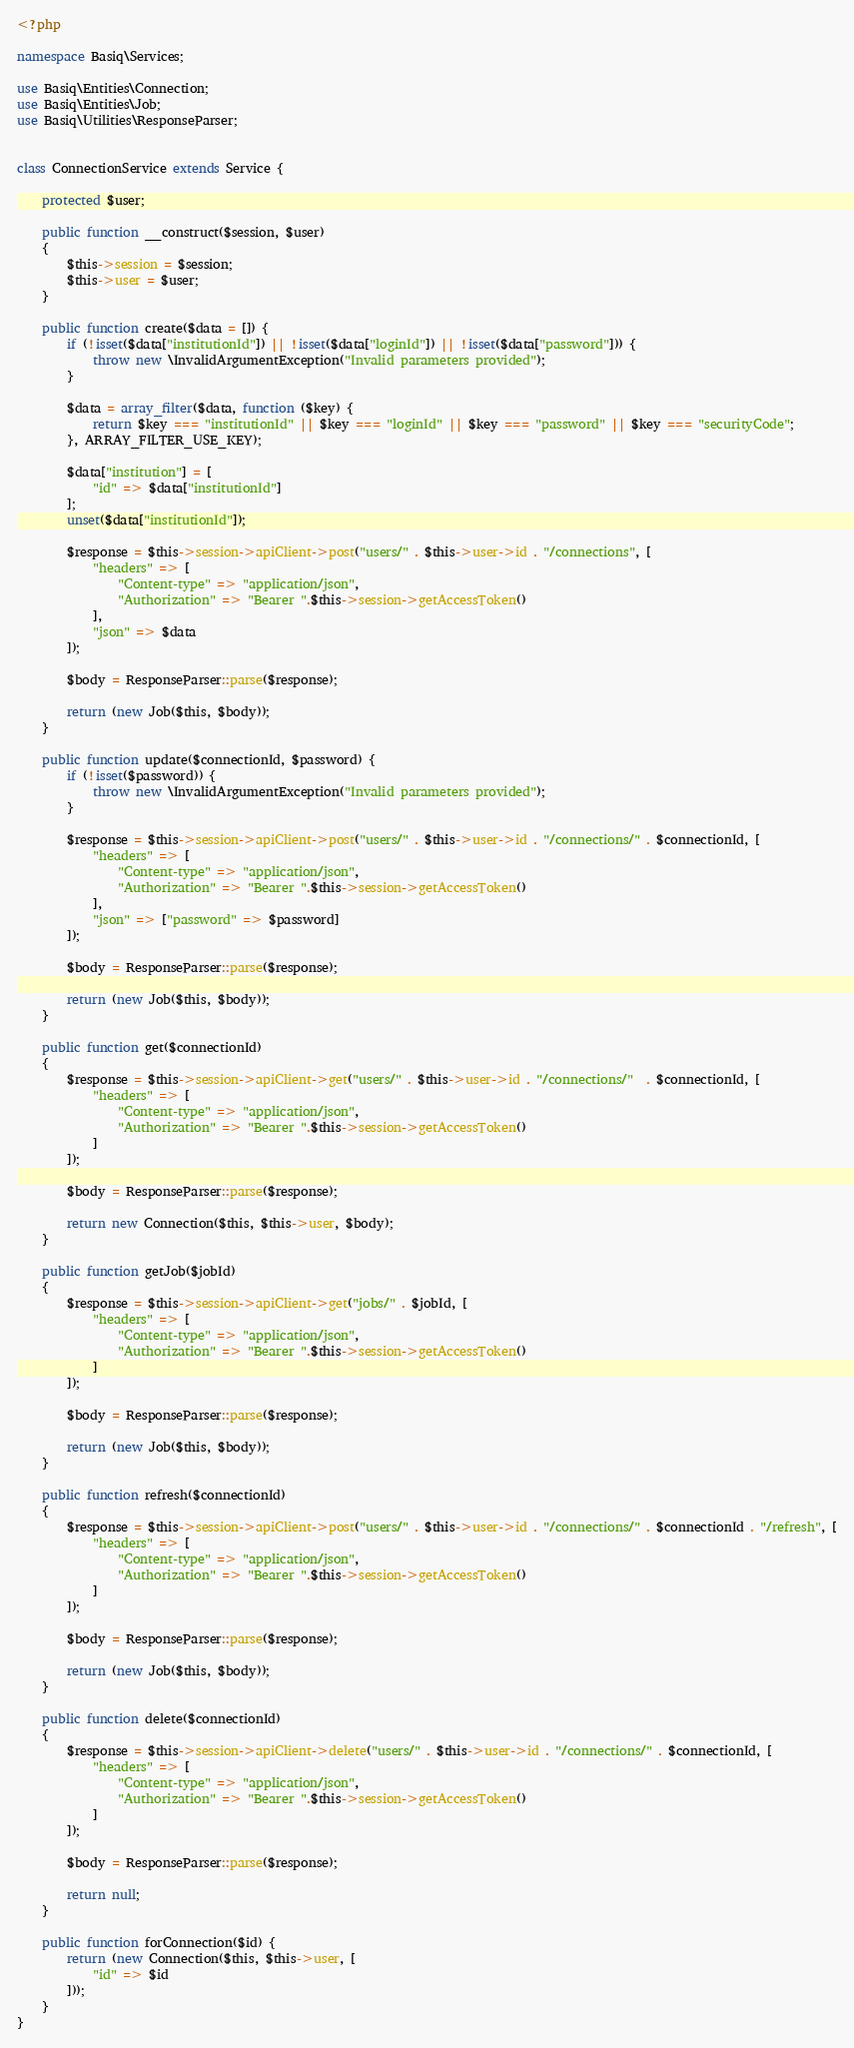<code> <loc_0><loc_0><loc_500><loc_500><_PHP_><?php 

namespace Basiq\Services;

use Basiq\Entities\Connection;
use Basiq\Entities\Job;
use Basiq\Utilities\ResponseParser;


class ConnectionService extends Service {

    protected $user;

    public function __construct($session, $user) 
    {
        $this->session = $session;
        $this->user = $user;
    }

    public function create($data = []) {
        if (!isset($data["institutionId"]) || !isset($data["loginId"]) || !isset($data["password"])) {
            throw new \InvalidArgumentException("Invalid parameters provided");
        }

        $data = array_filter($data, function ($key) {
            return $key === "institutionId" || $key === "loginId" || $key === "password" || $key === "securityCode";
        }, ARRAY_FILTER_USE_KEY);

        $data["institution"] = [
            "id" => $data["institutionId"]
        ];
        unset($data["institutionId"]);

        $response = $this->session->apiClient->post("users/" . $this->user->id . "/connections", [
            "headers" => [
                "Content-type" => "application/json",
                "Authorization" => "Bearer ".$this->session->getAccessToken()
            ],
            "json" => $data
        ]);

        $body = ResponseParser::parse($response);

        return (new Job($this, $body));
    }

    public function update($connectionId, $password) {
        if (!isset($password)) {
            throw new \InvalidArgumentException("Invalid parameters provided");
        }

        $response = $this->session->apiClient->post("users/" . $this->user->id . "/connections/" . $connectionId, [
            "headers" => [
                "Content-type" => "application/json",
                "Authorization" => "Bearer ".$this->session->getAccessToken()
            ],
            "json" => ["password" => $password]
        ]);

        $body = ResponseParser::parse($response);

        return (new Job($this, $body));
    }

    public function get($connectionId)
    {
        $response = $this->session->apiClient->get("users/" . $this->user->id . "/connections/"  . $connectionId, [
            "headers" => [
                "Content-type" => "application/json",
                "Authorization" => "Bearer ".$this->session->getAccessToken()
            ]
        ]);

        $body = ResponseParser::parse($response);

        return new Connection($this, $this->user, $body);
    }

    public function getJob($jobId)
    {
        $response = $this->session->apiClient->get("jobs/" . $jobId, [
            "headers" => [
                "Content-type" => "application/json",
                "Authorization" => "Bearer ".$this->session->getAccessToken()
            ]
        ]);

        $body = ResponseParser::parse($response);

        return (new Job($this, $body));
    }

    public function refresh($connectionId)
    {
        $response = $this->session->apiClient->post("users/" . $this->user->id . "/connections/" . $connectionId . "/refresh", [
            "headers" => [
                "Content-type" => "application/json",
                "Authorization" => "Bearer ".$this->session->getAccessToken()
            ]
        ]);

        $body = ResponseParser::parse($response);

        return (new Job($this, $body));
    }

    public function delete($connectionId)
    {
        $response = $this->session->apiClient->delete("users/" . $this->user->id . "/connections/" . $connectionId, [
            "headers" => [
                "Content-type" => "application/json",
                "Authorization" => "Bearer ".$this->session->getAccessToken()
            ]
        ]);

        $body = ResponseParser::parse($response);

        return null;
    }

    public function forConnection($id) {
        return (new Connection($this, $this->user, [
            "id" => $id
        ]));
    }
}</code> 